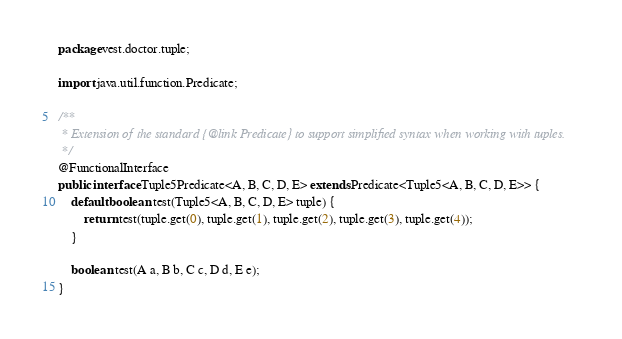<code> <loc_0><loc_0><loc_500><loc_500><_Java_>package vest.doctor.tuple;

import java.util.function.Predicate;

/**
 * Extension of the standard {@link Predicate} to support simplified syntax when working with tuples.
 */
@FunctionalInterface
public interface Tuple5Predicate<A, B, C, D, E> extends Predicate<Tuple5<A, B, C, D, E>> {
    default boolean test(Tuple5<A, B, C, D, E> tuple) {
        return test(tuple.get(0), tuple.get(1), tuple.get(2), tuple.get(3), tuple.get(4));
    }

    boolean test(A a, B b, C c, D d, E e);
}
</code> 